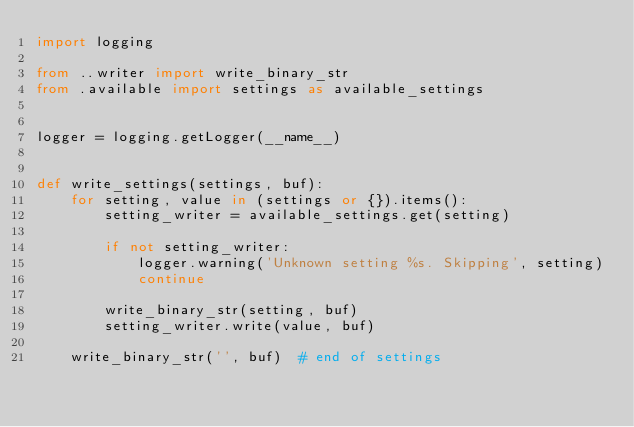<code> <loc_0><loc_0><loc_500><loc_500><_Python_>import logging

from ..writer import write_binary_str
from .available import settings as available_settings


logger = logging.getLogger(__name__)


def write_settings(settings, buf):
    for setting, value in (settings or {}).items():
        setting_writer = available_settings.get(setting)

        if not setting_writer:
            logger.warning('Unknown setting %s. Skipping', setting)
            continue

        write_binary_str(setting, buf)
        setting_writer.write(value, buf)

    write_binary_str('', buf)  # end of settings
</code> 